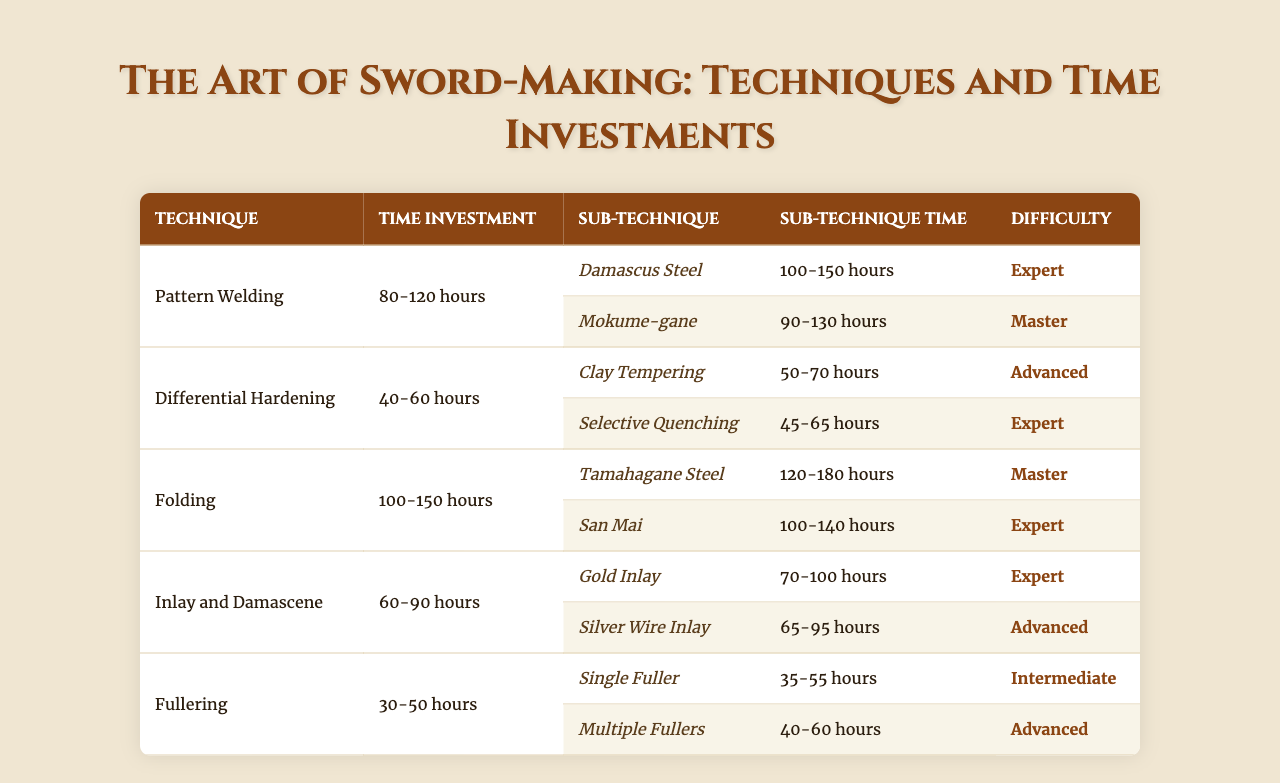What is the time investment range for Pattern Welding? The table lists the time investment for Pattern Welding as "80-120 hours".
Answer: 80-120 hours Which sub-technique of Folding requires the most time? The sub-technique Tamahagane Steel has the highest time requirement of "120-180 hours" within the Folding technique.
Answer: Tamahagane Steel Is there any sub-technique under Inlay and Damascene that has a time investment of less than 70 hours? Upon examining the times for both sub-techniques listed under Inlay and Damascene, Gold Inlay (70-100 hours) and Silver Wire Inlay (65-95 hours), Silver Wire Inlay qualifies as it ranges from 65 to 95 hours.
Answer: Yes What is the average time investment for Differential Hardening's sub-techniques? The time investments are 50-70 hours for Clay Tempering and 45-65 hours for Selective Quenching. The average would be calculated as follows: (60 + 55)/2 = 57.5 hours, considering midpoint values for a rough estimate.
Answer: 57.5 hours Which sword-making technique has the shortest time investment for sub-techniques and what is that time? The Fullering technique has a time investment range of "30-50 hours" for its sub-techniques, making it the shortest among all techniques presented.
Answer: Fullering, 30-50 hours If I sum the highest time investments of all main sword-making techniques, what is the total? The higher ends of the time investments are 120 hours (Pattern Welding), 60 hours (Differential Hardening), 150 hours (Folding), 90 hours (Inlay and Damascene), and 50 hours (Fullering). The total is 120 + 60 + 150 + 90 + 50 = 470 hours.
Answer: 470 hours What is the difficulty level of the sub-technique Selective Quenching? The Selective Quenching sub-technique is listed under Differential Hardening and has an associated difficulty of "Expert".
Answer: Expert Which technique contains the name of a legendary steel among its sub-techniques, and what is that technique? The Tamahagane Steel is known as a legendary steel and is a sub-technique under the Folding technique.
Answer: Folding, Tamahagane Steel 